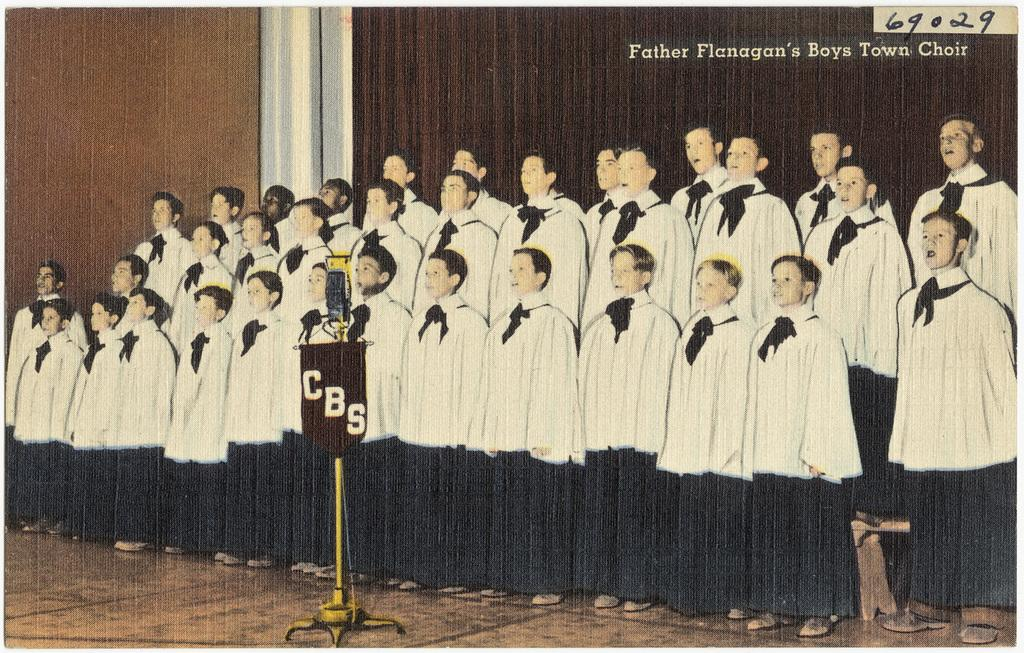How many people are in the image? There is a group of people in the image, but the exact number cannot be determined from the provided facts. What is the board on a stand used for in the image? The purpose of the board on a stand cannot be determined from the provided facts. What can be seen in the background of the image? There is a wall visible in the background of the image. What information is present in the top right corner of the image? There is text and a number in the top right corner of the image. Can you tell me how many ants are crawling on the board in the image? There are no ants present in the image; the board on a stand is the only object mentioned. What emotion are the people in the image expressing? The emotion of the people in the image cannot be determined from the provided facts. 